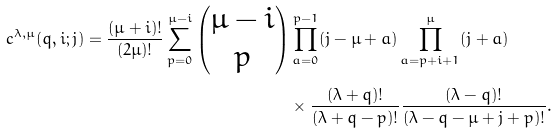Convert formula to latex. <formula><loc_0><loc_0><loc_500><loc_500>c ^ { \lambda , \mu } ( q , i ; j ) = \frac { ( \mu + i ) ! } { ( 2 \mu ) ! } \sum _ { p = 0 } ^ { \mu - i } \begin{pmatrix} \mu - i \\ p \end{pmatrix} & \prod _ { a = 0 } ^ { p - 1 } ( j - \mu + a ) \prod _ { a = p + i + 1 } ^ { \mu } ( j + a ) \\ & \times \frac { ( \lambda + q ) ! } { ( \lambda + q - p ) ! } \frac { ( \lambda - q ) ! } { ( \lambda - q - \mu + j + p ) ! } .</formula> 